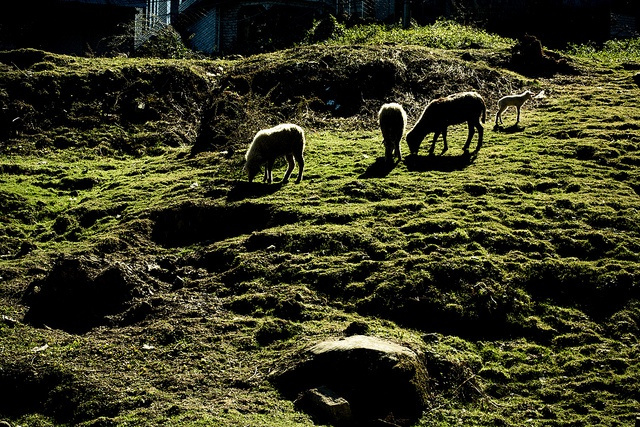Describe the objects in this image and their specific colors. I can see sheep in black, olive, and ivory tones, sheep in black, ivory, darkgreen, and khaki tones, sheep in black, ivory, khaki, and tan tones, sheep in black, white, darkgreen, and tan tones, and sheep in black, white, gray, and tan tones in this image. 